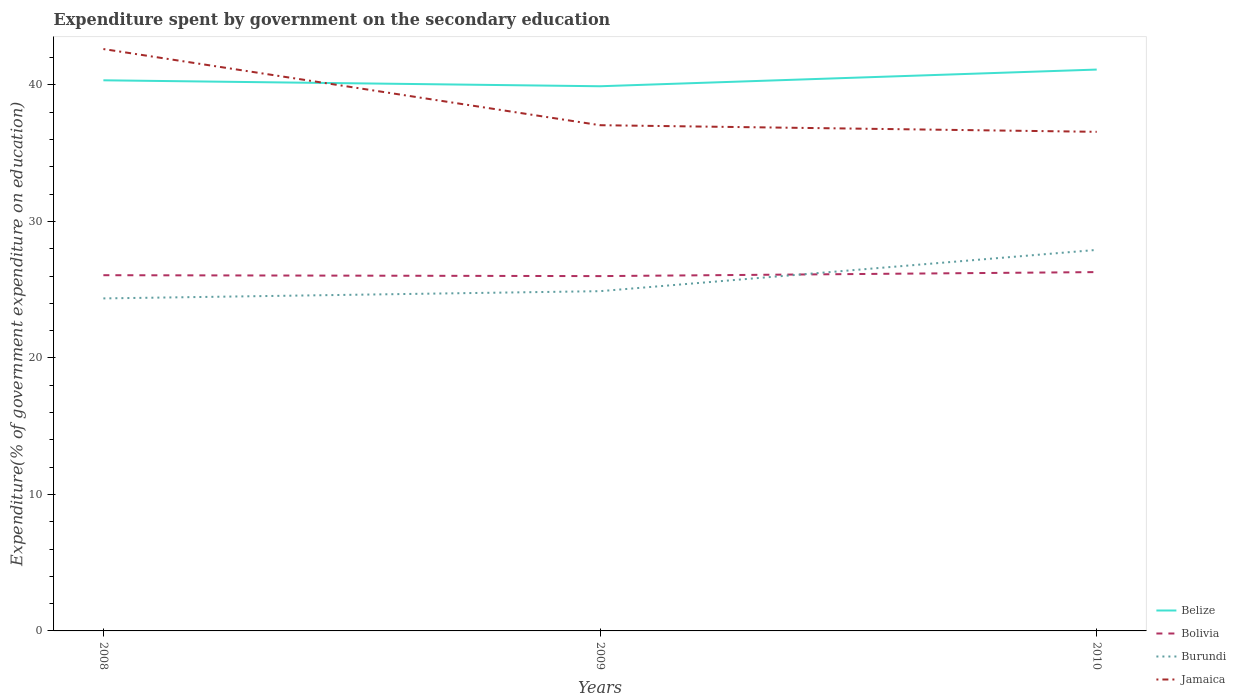Across all years, what is the maximum expenditure spent by government on the secondary education in Belize?
Make the answer very short. 39.91. In which year was the expenditure spent by government on the secondary education in Jamaica maximum?
Make the answer very short. 2010. What is the total expenditure spent by government on the secondary education in Bolivia in the graph?
Give a very brief answer. -0.23. What is the difference between the highest and the second highest expenditure spent by government on the secondary education in Bolivia?
Offer a terse response. 0.29. How many lines are there?
Your response must be concise. 4. How many years are there in the graph?
Offer a terse response. 3. Does the graph contain any zero values?
Offer a very short reply. No. Does the graph contain grids?
Your answer should be compact. No. How many legend labels are there?
Offer a very short reply. 4. What is the title of the graph?
Ensure brevity in your answer.  Expenditure spent by government on the secondary education. What is the label or title of the Y-axis?
Keep it short and to the point. Expenditure(% of government expenditure on education). What is the Expenditure(% of government expenditure on education) in Belize in 2008?
Ensure brevity in your answer.  40.34. What is the Expenditure(% of government expenditure on education) in Bolivia in 2008?
Offer a terse response. 26.06. What is the Expenditure(% of government expenditure on education) in Burundi in 2008?
Make the answer very short. 24.36. What is the Expenditure(% of government expenditure on education) in Jamaica in 2008?
Provide a short and direct response. 42.63. What is the Expenditure(% of government expenditure on education) of Belize in 2009?
Your answer should be very brief. 39.91. What is the Expenditure(% of government expenditure on education) of Bolivia in 2009?
Your answer should be compact. 26. What is the Expenditure(% of government expenditure on education) of Burundi in 2009?
Provide a succinct answer. 24.89. What is the Expenditure(% of government expenditure on education) in Jamaica in 2009?
Give a very brief answer. 37.05. What is the Expenditure(% of government expenditure on education) in Belize in 2010?
Provide a short and direct response. 41.13. What is the Expenditure(% of government expenditure on education) of Bolivia in 2010?
Provide a short and direct response. 26.29. What is the Expenditure(% of government expenditure on education) of Burundi in 2010?
Provide a short and direct response. 27.92. What is the Expenditure(% of government expenditure on education) in Jamaica in 2010?
Your answer should be very brief. 36.57. Across all years, what is the maximum Expenditure(% of government expenditure on education) in Belize?
Provide a succinct answer. 41.13. Across all years, what is the maximum Expenditure(% of government expenditure on education) of Bolivia?
Offer a terse response. 26.29. Across all years, what is the maximum Expenditure(% of government expenditure on education) in Burundi?
Give a very brief answer. 27.92. Across all years, what is the maximum Expenditure(% of government expenditure on education) of Jamaica?
Give a very brief answer. 42.63. Across all years, what is the minimum Expenditure(% of government expenditure on education) of Belize?
Keep it short and to the point. 39.91. Across all years, what is the minimum Expenditure(% of government expenditure on education) of Bolivia?
Provide a succinct answer. 26. Across all years, what is the minimum Expenditure(% of government expenditure on education) of Burundi?
Keep it short and to the point. 24.36. Across all years, what is the minimum Expenditure(% of government expenditure on education) of Jamaica?
Provide a succinct answer. 36.57. What is the total Expenditure(% of government expenditure on education) of Belize in the graph?
Provide a short and direct response. 121.38. What is the total Expenditure(% of government expenditure on education) of Bolivia in the graph?
Your answer should be very brief. 78.35. What is the total Expenditure(% of government expenditure on education) of Burundi in the graph?
Your response must be concise. 77.17. What is the total Expenditure(% of government expenditure on education) in Jamaica in the graph?
Provide a short and direct response. 116.25. What is the difference between the Expenditure(% of government expenditure on education) of Belize in 2008 and that in 2009?
Ensure brevity in your answer.  0.44. What is the difference between the Expenditure(% of government expenditure on education) in Bolivia in 2008 and that in 2009?
Your response must be concise. 0.07. What is the difference between the Expenditure(% of government expenditure on education) in Burundi in 2008 and that in 2009?
Make the answer very short. -0.53. What is the difference between the Expenditure(% of government expenditure on education) of Jamaica in 2008 and that in 2009?
Give a very brief answer. 5.58. What is the difference between the Expenditure(% of government expenditure on education) of Belize in 2008 and that in 2010?
Your response must be concise. -0.79. What is the difference between the Expenditure(% of government expenditure on education) in Bolivia in 2008 and that in 2010?
Make the answer very short. -0.23. What is the difference between the Expenditure(% of government expenditure on education) of Burundi in 2008 and that in 2010?
Your response must be concise. -3.56. What is the difference between the Expenditure(% of government expenditure on education) of Jamaica in 2008 and that in 2010?
Your response must be concise. 6.06. What is the difference between the Expenditure(% of government expenditure on education) of Belize in 2009 and that in 2010?
Give a very brief answer. -1.22. What is the difference between the Expenditure(% of government expenditure on education) of Bolivia in 2009 and that in 2010?
Give a very brief answer. -0.29. What is the difference between the Expenditure(% of government expenditure on education) of Burundi in 2009 and that in 2010?
Offer a very short reply. -3.02. What is the difference between the Expenditure(% of government expenditure on education) of Jamaica in 2009 and that in 2010?
Provide a succinct answer. 0.48. What is the difference between the Expenditure(% of government expenditure on education) of Belize in 2008 and the Expenditure(% of government expenditure on education) of Bolivia in 2009?
Provide a short and direct response. 14.35. What is the difference between the Expenditure(% of government expenditure on education) in Belize in 2008 and the Expenditure(% of government expenditure on education) in Burundi in 2009?
Keep it short and to the point. 15.45. What is the difference between the Expenditure(% of government expenditure on education) in Belize in 2008 and the Expenditure(% of government expenditure on education) in Jamaica in 2009?
Offer a very short reply. 3.29. What is the difference between the Expenditure(% of government expenditure on education) of Bolivia in 2008 and the Expenditure(% of government expenditure on education) of Burundi in 2009?
Offer a very short reply. 1.17. What is the difference between the Expenditure(% of government expenditure on education) of Bolivia in 2008 and the Expenditure(% of government expenditure on education) of Jamaica in 2009?
Provide a succinct answer. -10.99. What is the difference between the Expenditure(% of government expenditure on education) in Burundi in 2008 and the Expenditure(% of government expenditure on education) in Jamaica in 2009?
Provide a succinct answer. -12.69. What is the difference between the Expenditure(% of government expenditure on education) of Belize in 2008 and the Expenditure(% of government expenditure on education) of Bolivia in 2010?
Keep it short and to the point. 14.05. What is the difference between the Expenditure(% of government expenditure on education) of Belize in 2008 and the Expenditure(% of government expenditure on education) of Burundi in 2010?
Provide a short and direct response. 12.43. What is the difference between the Expenditure(% of government expenditure on education) of Belize in 2008 and the Expenditure(% of government expenditure on education) of Jamaica in 2010?
Keep it short and to the point. 3.78. What is the difference between the Expenditure(% of government expenditure on education) of Bolivia in 2008 and the Expenditure(% of government expenditure on education) of Burundi in 2010?
Your response must be concise. -1.85. What is the difference between the Expenditure(% of government expenditure on education) in Bolivia in 2008 and the Expenditure(% of government expenditure on education) in Jamaica in 2010?
Your answer should be compact. -10.5. What is the difference between the Expenditure(% of government expenditure on education) of Burundi in 2008 and the Expenditure(% of government expenditure on education) of Jamaica in 2010?
Make the answer very short. -12.21. What is the difference between the Expenditure(% of government expenditure on education) of Belize in 2009 and the Expenditure(% of government expenditure on education) of Bolivia in 2010?
Ensure brevity in your answer.  13.62. What is the difference between the Expenditure(% of government expenditure on education) in Belize in 2009 and the Expenditure(% of government expenditure on education) in Burundi in 2010?
Provide a succinct answer. 11.99. What is the difference between the Expenditure(% of government expenditure on education) of Belize in 2009 and the Expenditure(% of government expenditure on education) of Jamaica in 2010?
Offer a very short reply. 3.34. What is the difference between the Expenditure(% of government expenditure on education) of Bolivia in 2009 and the Expenditure(% of government expenditure on education) of Burundi in 2010?
Offer a terse response. -1.92. What is the difference between the Expenditure(% of government expenditure on education) in Bolivia in 2009 and the Expenditure(% of government expenditure on education) in Jamaica in 2010?
Provide a short and direct response. -10.57. What is the difference between the Expenditure(% of government expenditure on education) in Burundi in 2009 and the Expenditure(% of government expenditure on education) in Jamaica in 2010?
Provide a succinct answer. -11.67. What is the average Expenditure(% of government expenditure on education) of Belize per year?
Make the answer very short. 40.46. What is the average Expenditure(% of government expenditure on education) of Bolivia per year?
Your answer should be compact. 26.12. What is the average Expenditure(% of government expenditure on education) in Burundi per year?
Offer a very short reply. 25.72. What is the average Expenditure(% of government expenditure on education) in Jamaica per year?
Make the answer very short. 38.75. In the year 2008, what is the difference between the Expenditure(% of government expenditure on education) in Belize and Expenditure(% of government expenditure on education) in Bolivia?
Provide a succinct answer. 14.28. In the year 2008, what is the difference between the Expenditure(% of government expenditure on education) of Belize and Expenditure(% of government expenditure on education) of Burundi?
Provide a succinct answer. 15.98. In the year 2008, what is the difference between the Expenditure(% of government expenditure on education) of Belize and Expenditure(% of government expenditure on education) of Jamaica?
Offer a very short reply. -2.29. In the year 2008, what is the difference between the Expenditure(% of government expenditure on education) of Bolivia and Expenditure(% of government expenditure on education) of Burundi?
Your response must be concise. 1.7. In the year 2008, what is the difference between the Expenditure(% of government expenditure on education) in Bolivia and Expenditure(% of government expenditure on education) in Jamaica?
Ensure brevity in your answer.  -16.57. In the year 2008, what is the difference between the Expenditure(% of government expenditure on education) of Burundi and Expenditure(% of government expenditure on education) of Jamaica?
Give a very brief answer. -18.27. In the year 2009, what is the difference between the Expenditure(% of government expenditure on education) in Belize and Expenditure(% of government expenditure on education) in Bolivia?
Make the answer very short. 13.91. In the year 2009, what is the difference between the Expenditure(% of government expenditure on education) in Belize and Expenditure(% of government expenditure on education) in Burundi?
Keep it short and to the point. 15.01. In the year 2009, what is the difference between the Expenditure(% of government expenditure on education) of Belize and Expenditure(% of government expenditure on education) of Jamaica?
Give a very brief answer. 2.85. In the year 2009, what is the difference between the Expenditure(% of government expenditure on education) in Bolivia and Expenditure(% of government expenditure on education) in Burundi?
Your response must be concise. 1.1. In the year 2009, what is the difference between the Expenditure(% of government expenditure on education) of Bolivia and Expenditure(% of government expenditure on education) of Jamaica?
Ensure brevity in your answer.  -11.06. In the year 2009, what is the difference between the Expenditure(% of government expenditure on education) in Burundi and Expenditure(% of government expenditure on education) in Jamaica?
Offer a very short reply. -12.16. In the year 2010, what is the difference between the Expenditure(% of government expenditure on education) of Belize and Expenditure(% of government expenditure on education) of Bolivia?
Your response must be concise. 14.84. In the year 2010, what is the difference between the Expenditure(% of government expenditure on education) in Belize and Expenditure(% of government expenditure on education) in Burundi?
Your answer should be very brief. 13.21. In the year 2010, what is the difference between the Expenditure(% of government expenditure on education) in Belize and Expenditure(% of government expenditure on education) in Jamaica?
Your response must be concise. 4.56. In the year 2010, what is the difference between the Expenditure(% of government expenditure on education) in Bolivia and Expenditure(% of government expenditure on education) in Burundi?
Keep it short and to the point. -1.63. In the year 2010, what is the difference between the Expenditure(% of government expenditure on education) of Bolivia and Expenditure(% of government expenditure on education) of Jamaica?
Provide a succinct answer. -10.28. In the year 2010, what is the difference between the Expenditure(% of government expenditure on education) in Burundi and Expenditure(% of government expenditure on education) in Jamaica?
Your answer should be very brief. -8.65. What is the ratio of the Expenditure(% of government expenditure on education) in Belize in 2008 to that in 2009?
Your answer should be compact. 1.01. What is the ratio of the Expenditure(% of government expenditure on education) of Burundi in 2008 to that in 2009?
Your answer should be compact. 0.98. What is the ratio of the Expenditure(% of government expenditure on education) of Jamaica in 2008 to that in 2009?
Keep it short and to the point. 1.15. What is the ratio of the Expenditure(% of government expenditure on education) of Belize in 2008 to that in 2010?
Your answer should be very brief. 0.98. What is the ratio of the Expenditure(% of government expenditure on education) in Bolivia in 2008 to that in 2010?
Offer a terse response. 0.99. What is the ratio of the Expenditure(% of government expenditure on education) of Burundi in 2008 to that in 2010?
Your response must be concise. 0.87. What is the ratio of the Expenditure(% of government expenditure on education) of Jamaica in 2008 to that in 2010?
Make the answer very short. 1.17. What is the ratio of the Expenditure(% of government expenditure on education) in Belize in 2009 to that in 2010?
Provide a succinct answer. 0.97. What is the ratio of the Expenditure(% of government expenditure on education) in Burundi in 2009 to that in 2010?
Keep it short and to the point. 0.89. What is the ratio of the Expenditure(% of government expenditure on education) in Jamaica in 2009 to that in 2010?
Keep it short and to the point. 1.01. What is the difference between the highest and the second highest Expenditure(% of government expenditure on education) of Belize?
Provide a succinct answer. 0.79. What is the difference between the highest and the second highest Expenditure(% of government expenditure on education) of Bolivia?
Your response must be concise. 0.23. What is the difference between the highest and the second highest Expenditure(% of government expenditure on education) of Burundi?
Your answer should be very brief. 3.02. What is the difference between the highest and the second highest Expenditure(% of government expenditure on education) in Jamaica?
Your response must be concise. 5.58. What is the difference between the highest and the lowest Expenditure(% of government expenditure on education) of Belize?
Ensure brevity in your answer.  1.22. What is the difference between the highest and the lowest Expenditure(% of government expenditure on education) of Bolivia?
Give a very brief answer. 0.29. What is the difference between the highest and the lowest Expenditure(% of government expenditure on education) of Burundi?
Make the answer very short. 3.56. What is the difference between the highest and the lowest Expenditure(% of government expenditure on education) of Jamaica?
Offer a very short reply. 6.06. 